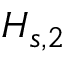Convert formula to latex. <formula><loc_0><loc_0><loc_500><loc_500>H _ { s , 2 }</formula> 